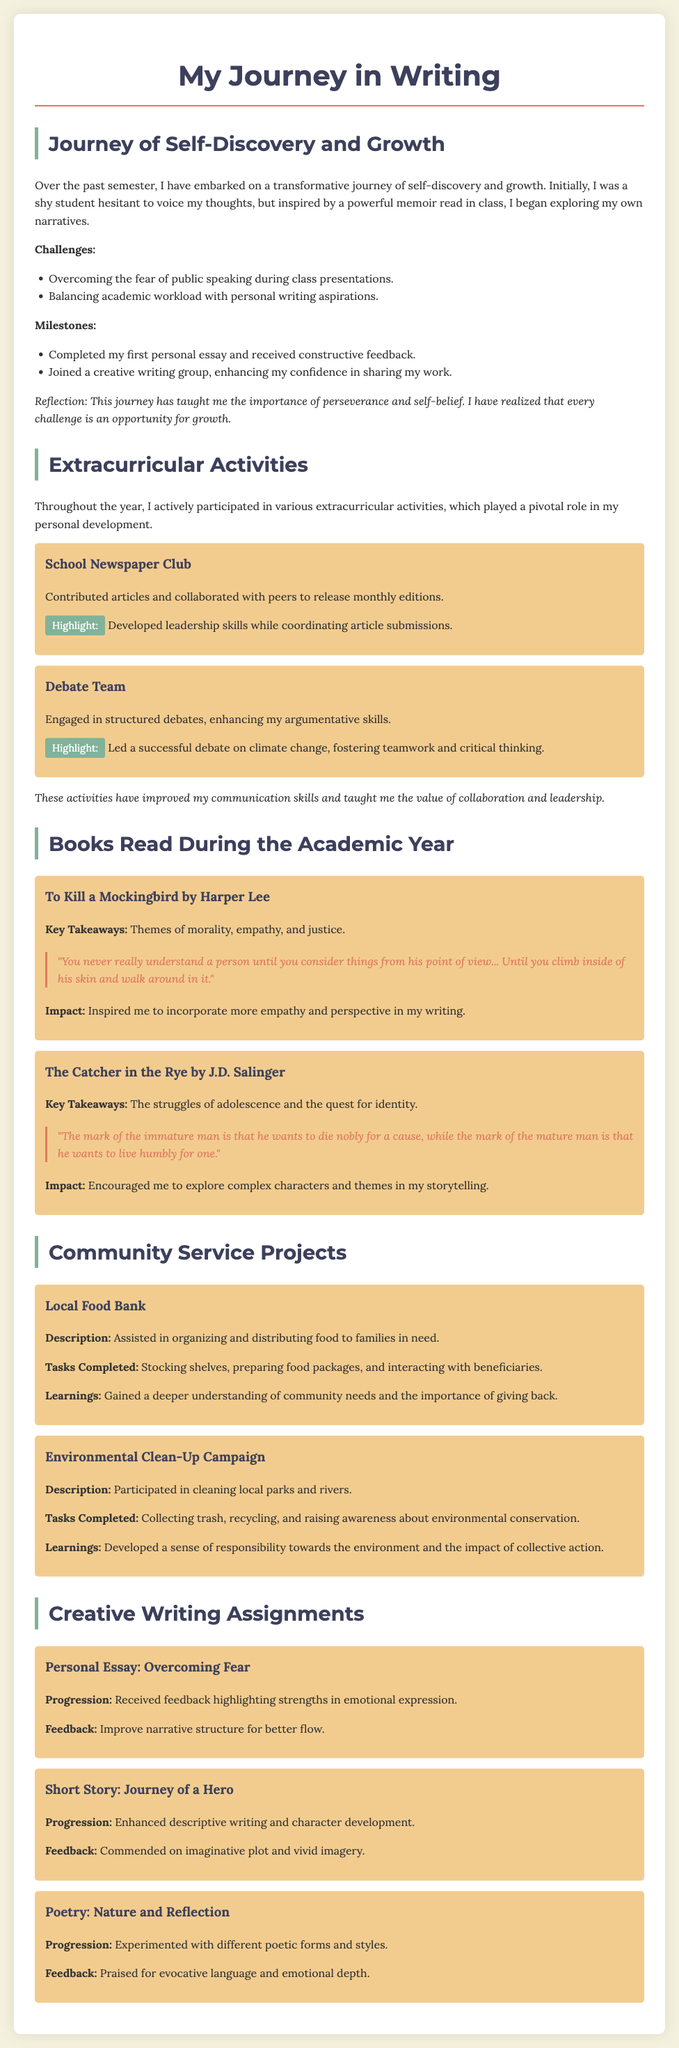What is the title of the document? The title of the document is stated at the top and is "My Journey in Writing."
Answer: My Journey in Writing How many activities are listed under Extracurricular Activities? There are two activities mentioned: School Newspaper Club and Debate Team.
Answer: Two What was a key takeaway from "To Kill a Mockingbird"? The key takeaway is highlighted in the summary of the book and is about themes of morality, empathy, and justice.
Answer: Morality, empathy, and justice What challenges did the author face in their journey of self-discovery? The challenges listed include overcoming the fear of public speaking and balancing academic workload with personal writing aspirations.
Answer: Fear of public speaking and balancing workload What community service project involved cleaning local parks? The project mentioned that involved cleaning local parks is the Environmental Clean-Up Campaign.
Answer: Environmental Clean-Up Campaign Which writing assignment received feedback praising its emotional expression? The Personal Essay on overcoming fear received feedback highlighting strengths in emotional expression.
Answer: Personal Essay: Overcoming Fear What does the author reflect on as a lesson learned from their journey? The author reflects on the importance of perseverance and self-belief from their journey of self-discovery.
Answer: Perseverance and self-belief What highlight is noted for the Debate Team? The highlight mentioned for the Debate Team is leading a successful debate on climate change.
Answer: Leading a successful debate on climate change 